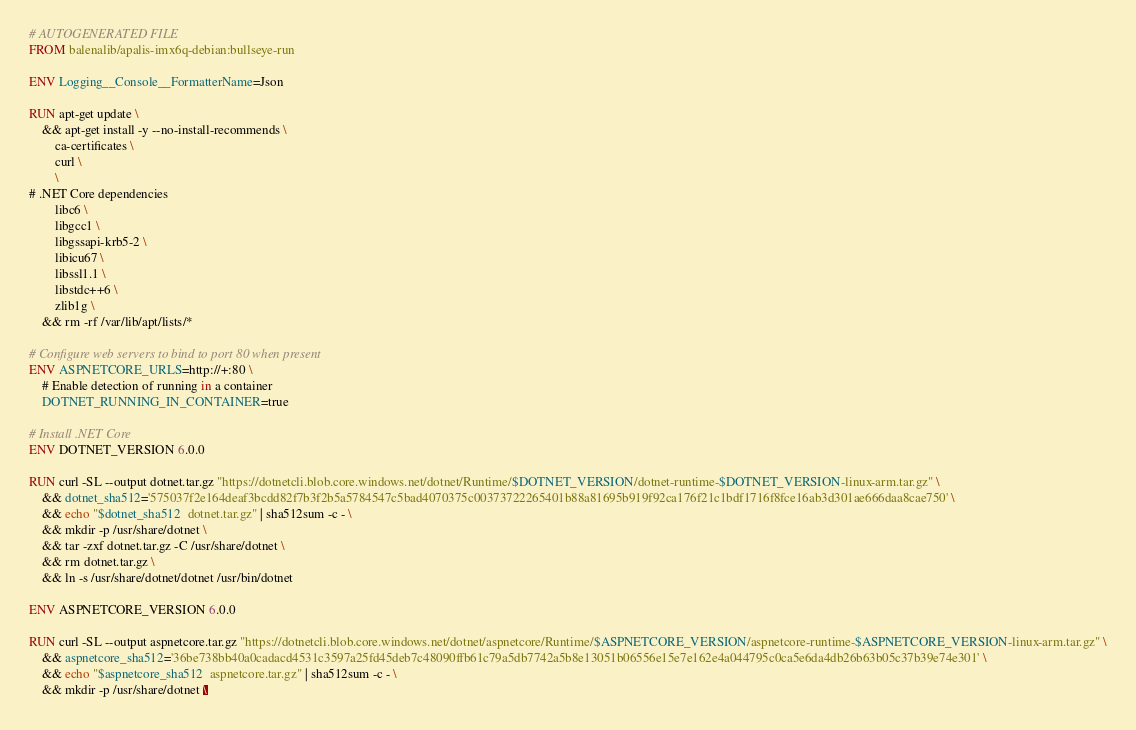<code> <loc_0><loc_0><loc_500><loc_500><_Dockerfile_># AUTOGENERATED FILE
FROM balenalib/apalis-imx6q-debian:bullseye-run

ENV Logging__Console__FormatterName=Json

RUN apt-get update \
    && apt-get install -y --no-install-recommends \
        ca-certificates \
        curl \
        \
# .NET Core dependencies
        libc6 \
        libgcc1 \
        libgssapi-krb5-2 \
        libicu67 \
        libssl1.1 \
        libstdc++6 \
        zlib1g \
    && rm -rf /var/lib/apt/lists/*

# Configure web servers to bind to port 80 when present
ENV ASPNETCORE_URLS=http://+:80 \
    # Enable detection of running in a container
    DOTNET_RUNNING_IN_CONTAINER=true

# Install .NET Core
ENV DOTNET_VERSION 6.0.0

RUN curl -SL --output dotnet.tar.gz "https://dotnetcli.blob.core.windows.net/dotnet/Runtime/$DOTNET_VERSION/dotnet-runtime-$DOTNET_VERSION-linux-arm.tar.gz" \
    && dotnet_sha512='575037f2e164deaf3bcdd82f7b3f2b5a5784547c5bad4070375c00373722265401b88a81695b919f92ca176f21c1bdf1716f8fce16ab3d301ae666daa8cae750' \
    && echo "$dotnet_sha512  dotnet.tar.gz" | sha512sum -c - \
    && mkdir -p /usr/share/dotnet \
    && tar -zxf dotnet.tar.gz -C /usr/share/dotnet \
    && rm dotnet.tar.gz \
    && ln -s /usr/share/dotnet/dotnet /usr/bin/dotnet

ENV ASPNETCORE_VERSION 6.0.0

RUN curl -SL --output aspnetcore.tar.gz "https://dotnetcli.blob.core.windows.net/dotnet/aspnetcore/Runtime/$ASPNETCORE_VERSION/aspnetcore-runtime-$ASPNETCORE_VERSION-linux-arm.tar.gz" \
    && aspnetcore_sha512='36be738bb40a0cadacd4531c3597a25fd45deb7c48090ffb61c79a5db7742a5b8e13051b06556e15e7e162e4a044795c0ca5e6da4db26b63b05c37b39e74e301' \
    && echo "$aspnetcore_sha512  aspnetcore.tar.gz" | sha512sum -c - \
    && mkdir -p /usr/share/dotnet \</code> 